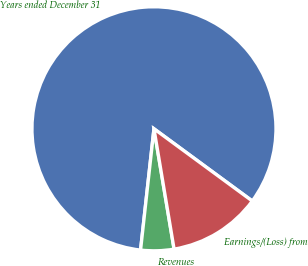Convert chart to OTSL. <chart><loc_0><loc_0><loc_500><loc_500><pie_chart><fcel>Years ended December 31<fcel>Revenues<fcel>Earnings/(Loss) from<nl><fcel>83.33%<fcel>4.39%<fcel>12.28%<nl></chart> 